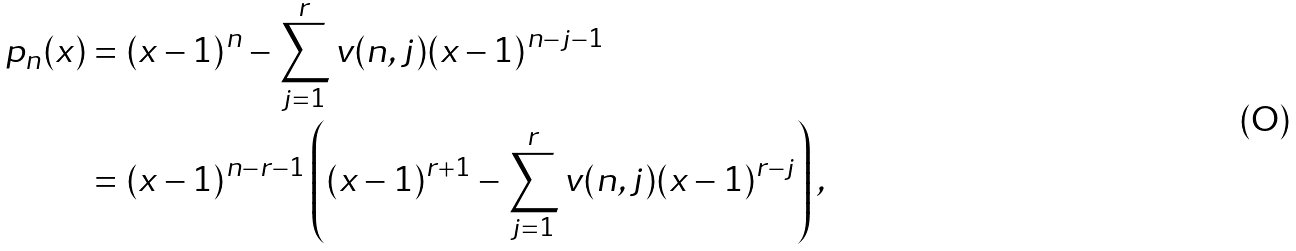<formula> <loc_0><loc_0><loc_500><loc_500>p _ { n } ( x ) & = ( x - 1 ) ^ { n } - \sum _ { j = 1 } ^ { r } v ( n , j ) ( x - 1 ) ^ { n - j - 1 } \\ & = ( x - 1 ) ^ { n - r - 1 } \left ( ( x - 1 ) ^ { r + 1 } - \sum _ { j = 1 } ^ { r } v ( n , j ) ( x - 1 ) ^ { r - j } \right ) ,</formula> 